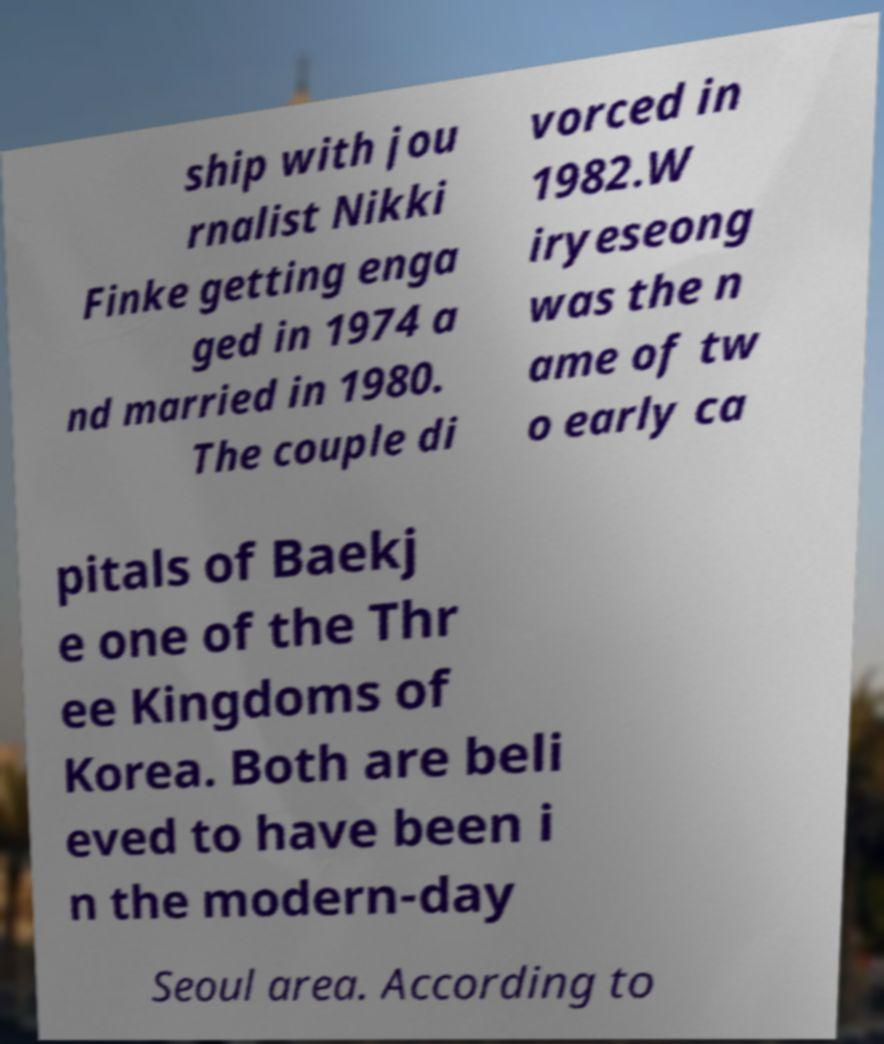Can you read and provide the text displayed in the image?This photo seems to have some interesting text. Can you extract and type it out for me? ship with jou rnalist Nikki Finke getting enga ged in 1974 a nd married in 1980. The couple di vorced in 1982.W iryeseong was the n ame of tw o early ca pitals of Baekj e one of the Thr ee Kingdoms of Korea. Both are beli eved to have been i n the modern-day Seoul area. According to 